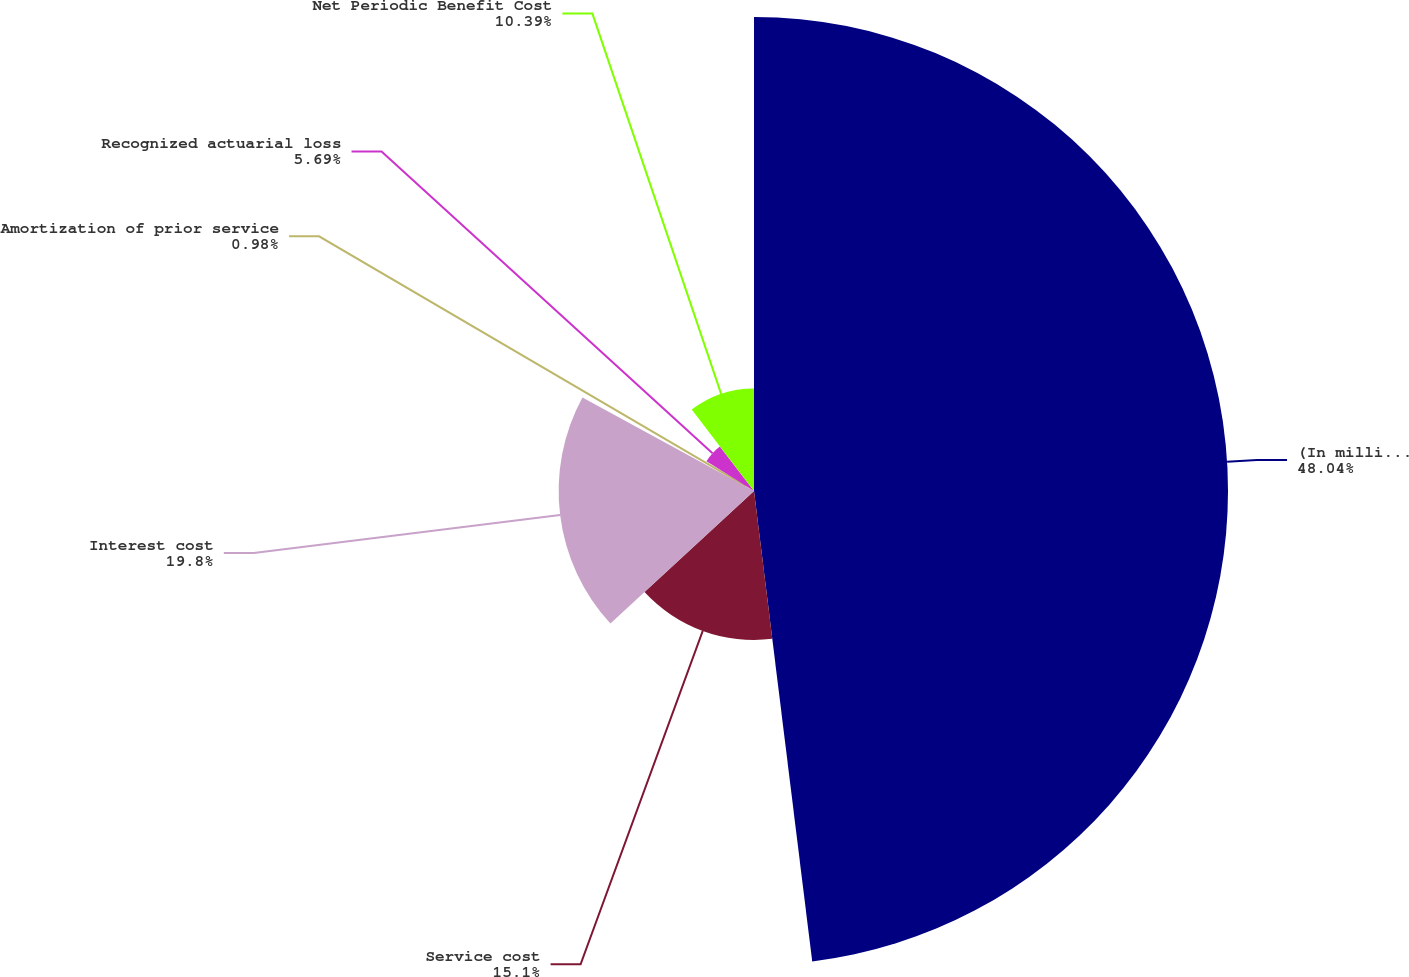<chart> <loc_0><loc_0><loc_500><loc_500><pie_chart><fcel>(In millions of dollars)<fcel>Service cost<fcel>Interest cost<fcel>Amortization of prior service<fcel>Recognized actuarial loss<fcel>Net Periodic Benefit Cost<nl><fcel>48.04%<fcel>15.1%<fcel>19.8%<fcel>0.98%<fcel>5.69%<fcel>10.39%<nl></chart> 